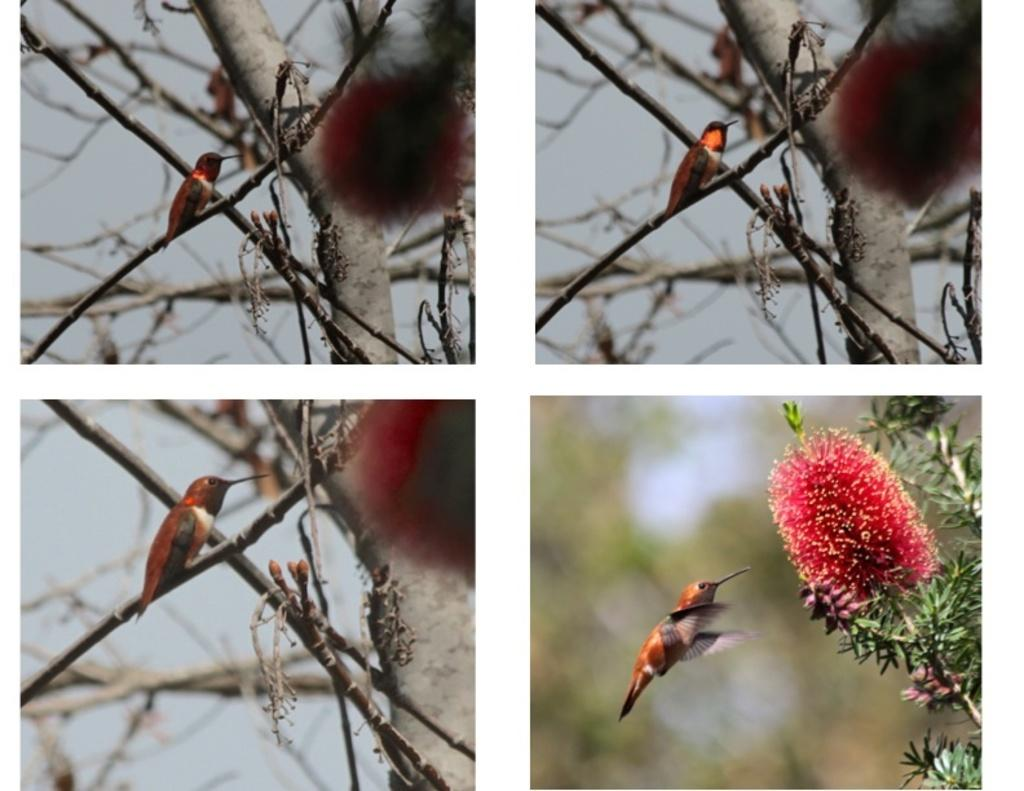How many pictures are present in the image? There are four pictures in the image. What can be seen in the pictures? In the pictures, there are birds, branches, sky, leaves, and flowers. What type of steel is used to create the art in the image? There is no steel or art present in the image; it features four pictures with birds, branches, sky, leaves, and flowers. 